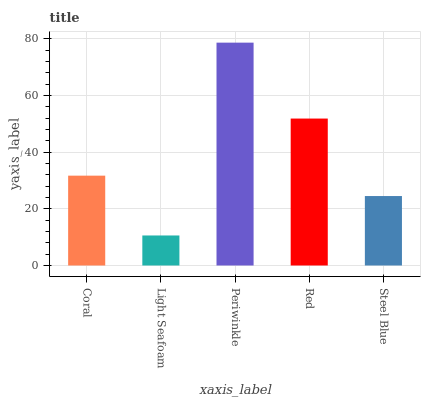Is Light Seafoam the minimum?
Answer yes or no. Yes. Is Periwinkle the maximum?
Answer yes or no. Yes. Is Periwinkle the minimum?
Answer yes or no. No. Is Light Seafoam the maximum?
Answer yes or no. No. Is Periwinkle greater than Light Seafoam?
Answer yes or no. Yes. Is Light Seafoam less than Periwinkle?
Answer yes or no. Yes. Is Light Seafoam greater than Periwinkle?
Answer yes or no. No. Is Periwinkle less than Light Seafoam?
Answer yes or no. No. Is Coral the high median?
Answer yes or no. Yes. Is Coral the low median?
Answer yes or no. Yes. Is Light Seafoam the high median?
Answer yes or no. No. Is Steel Blue the low median?
Answer yes or no. No. 